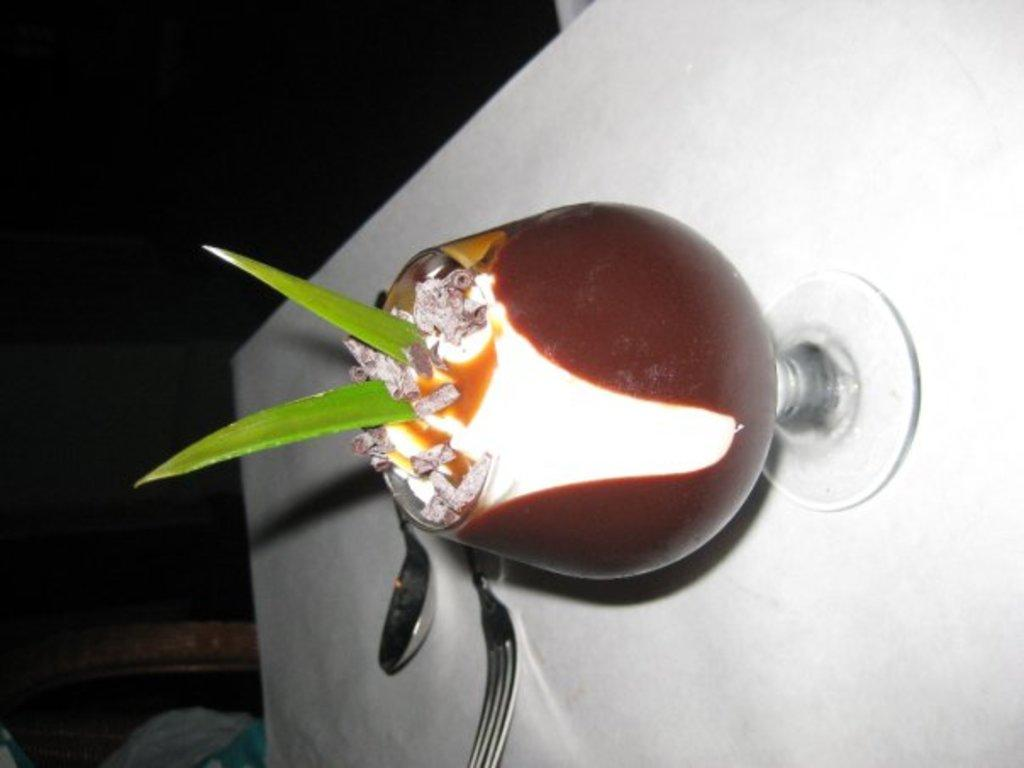What is in the glass that is visible in the image? There is a glass of drink in the image. What is inside the glass of drink? The glass of drink contains two aloe vera strips. What utensils are present beside the glass? There is a spoon and a fork beside the glass. What type of car is parked next to the glass of drink in the image? There is no car present in the image; it only features a glass of drink, aloe vera strips, a spoon, and a fork. 